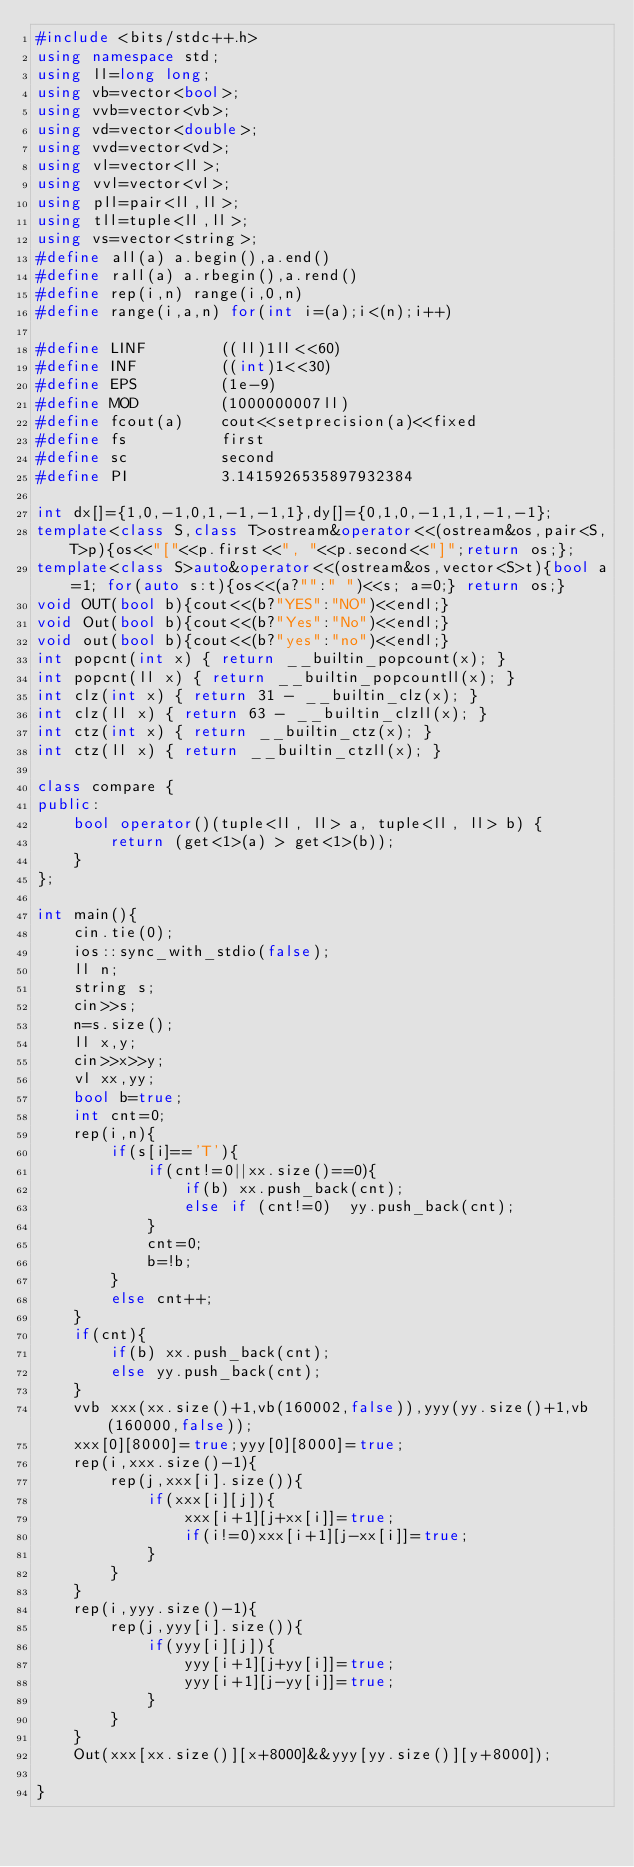Convert code to text. <code><loc_0><loc_0><loc_500><loc_500><_C++_>#include <bits/stdc++.h>
using namespace std;
using ll=long long;
using vb=vector<bool>;
using vvb=vector<vb>;
using vd=vector<double>;
using vvd=vector<vd>;
using vl=vector<ll>;
using vvl=vector<vl>;
using pll=pair<ll,ll>;
using tll=tuple<ll,ll>;
using vs=vector<string>;
#define all(a) a.begin(),a.end()
#define rall(a) a.rbegin(),a.rend()
#define rep(i,n) range(i,0,n)
#define range(i,a,n) for(int i=(a);i<(n);i++)

#define LINF    	((ll)1ll<<60)
#define INF     	((int)1<<30)
#define EPS     	(1e-9)
#define MOD     	(1000000007ll)
#define fcout(a)	cout<<setprecision(a)<<fixed
#define fs 			first
#define sc			second
#define PI			3.1415926535897932384

int dx[]={1,0,-1,0,1,-1,-1,1},dy[]={0,1,0,-1,1,1,-1,-1};
template<class S,class T>ostream&operator<<(ostream&os,pair<S,T>p){os<<"["<<p.first<<", "<<p.second<<"]";return os;};
template<class S>auto&operator<<(ostream&os,vector<S>t){bool a=1; for(auto s:t){os<<(a?"":" ")<<s; a=0;} return os;}
void OUT(bool b){cout<<(b?"YES":"NO")<<endl;}
void Out(bool b){cout<<(b?"Yes":"No")<<endl;}
void out(bool b){cout<<(b?"yes":"no")<<endl;}
int popcnt(int x) { return __builtin_popcount(x); }
int popcnt(ll x) { return __builtin_popcountll(x); }
int clz(int x) { return 31 - __builtin_clz(x); }
int clz(ll x) { return 63 - __builtin_clzll(x); }
int ctz(int x) { return __builtin_ctz(x); }
int ctz(ll x) { return __builtin_ctzll(x); }

class compare {
public:
	bool operator()(tuple<ll, ll> a, tuple<ll, ll> b) {
		return (get<1>(a) > get<1>(b));
	}
};

int main(){
	cin.tie(0);
	ios::sync_with_stdio(false);
	ll n;
	string s;
	cin>>s;
	n=s.size();
	ll x,y;
	cin>>x>>y;
	vl xx,yy;
	bool b=true;
	int cnt=0;
	rep(i,n){
		if(s[i]=='T'){
			if(cnt!=0||xx.size()==0){
				if(b) xx.push_back(cnt);
				else if (cnt!=0)  yy.push_back(cnt);
			}
			cnt=0;
			b=!b;
		}
		else cnt++;	
	}
	if(cnt){
		if(b) xx.push_back(cnt);
		else yy.push_back(cnt);
	}
	vvb xxx(xx.size()+1,vb(160002,false)),yyy(yy.size()+1,vb(160000,false));
	xxx[0][8000]=true;yyy[0][8000]=true;
	rep(i,xxx.size()-1){
		rep(j,xxx[i].size()){
			if(xxx[i][j]){
				xxx[i+1][j+xx[i]]=true;
				if(i!=0)xxx[i+1][j-xx[i]]=true;
			}
		}
	}
	rep(i,yyy.size()-1){
		rep(j,yyy[i].size()){
			if(yyy[i][j]){
				yyy[i+1][j+yy[i]]=true;
				yyy[i+1][j-yy[i]]=true;
			}
		}
	}
	Out(xxx[xx.size()][x+8000]&&yyy[yy.size()][y+8000]);

}
</code> 